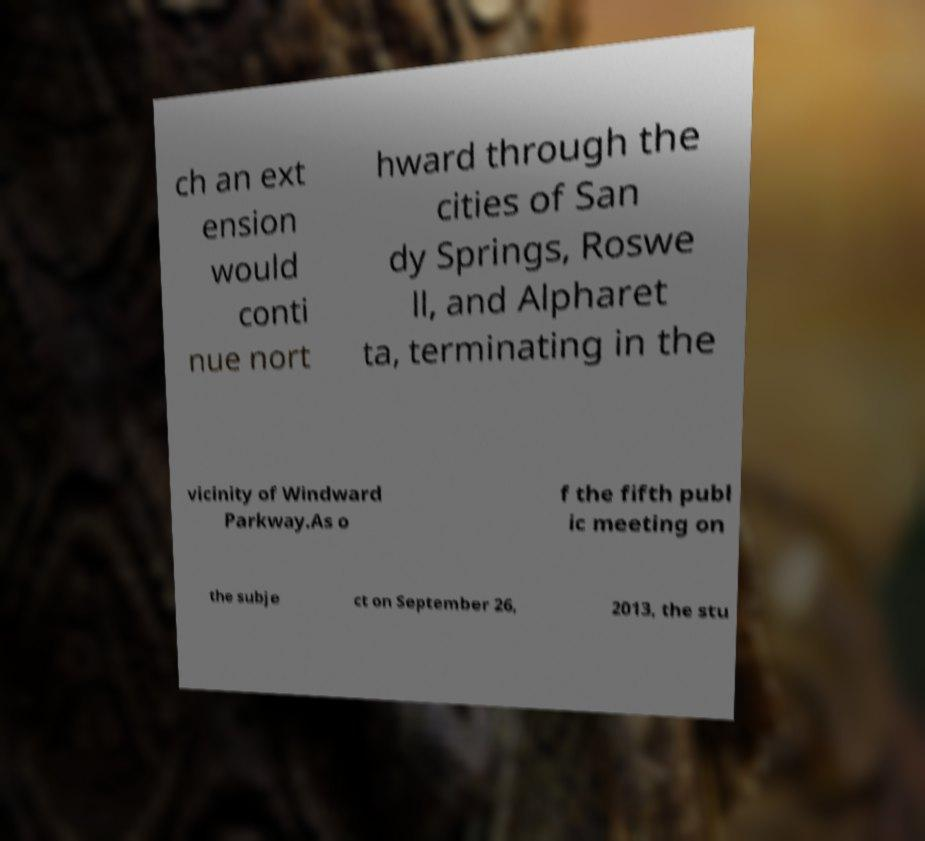Can you read and provide the text displayed in the image?This photo seems to have some interesting text. Can you extract and type it out for me? ch an ext ension would conti nue nort hward through the cities of San dy Springs, Roswe ll, and Alpharet ta, terminating in the vicinity of Windward Parkway.As o f the fifth publ ic meeting on the subje ct on September 26, 2013, the stu 